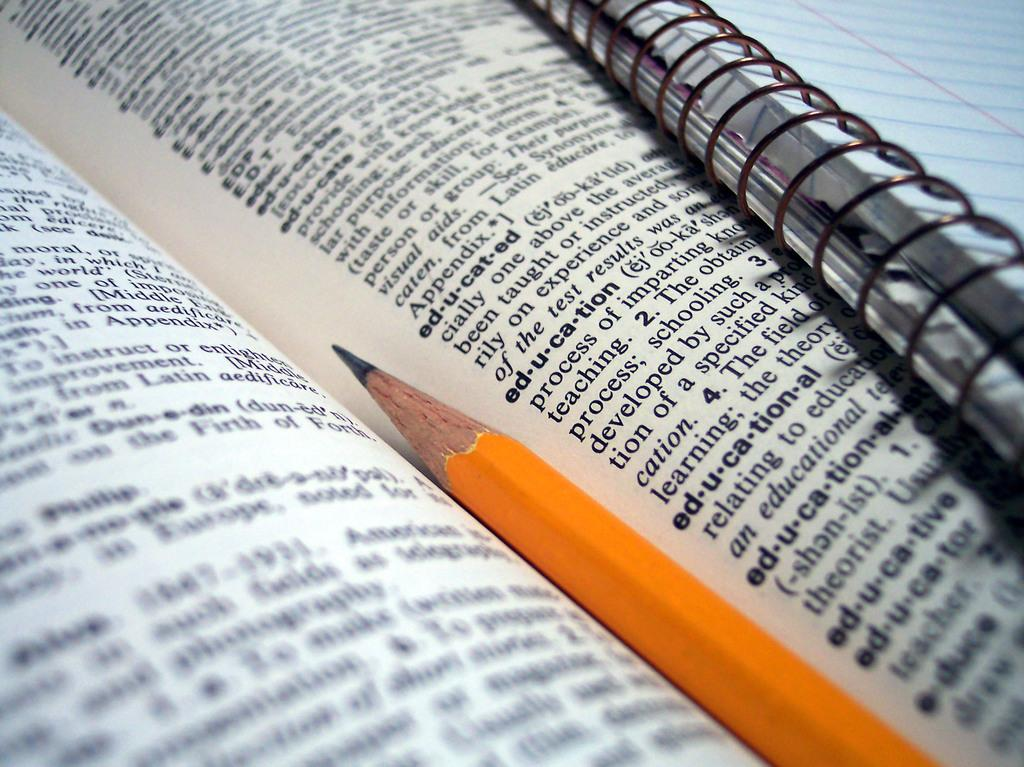<image>
Offer a succinct explanation of the picture presented. A dictionary opened to a page with e words and with a pencil between the pages. 